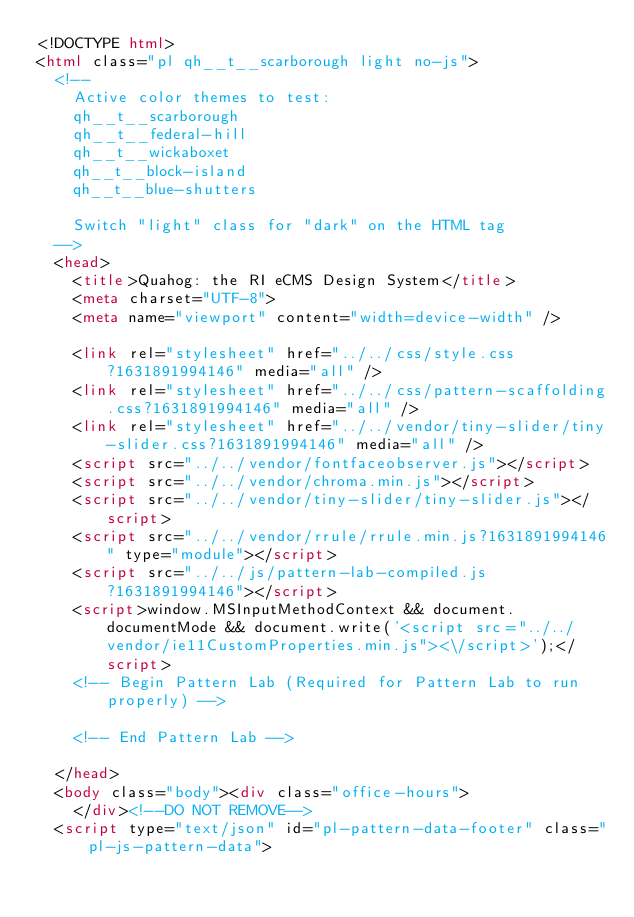Convert code to text. <code><loc_0><loc_0><loc_500><loc_500><_HTML_><!DOCTYPE html>
<html class="pl qh__t__scarborough light no-js">
  <!--
    Active color themes to test:
    qh__t__scarborough
    qh__t__federal-hill
    qh__t__wickaboxet
    qh__t__block-island
    qh__t__blue-shutters

    Switch "light" class for "dark" on the HTML tag
  -->
  <head>
    <title>Quahog: the RI eCMS Design System</title>
    <meta charset="UTF-8">
    <meta name="viewport" content="width=device-width" />

    <link rel="stylesheet" href="../../css/style.css?1631891994146" media="all" />
    <link rel="stylesheet" href="../../css/pattern-scaffolding.css?1631891994146" media="all" />
    <link rel="stylesheet" href="../../vendor/tiny-slider/tiny-slider.css?1631891994146" media="all" />
    <script src="../../vendor/fontfaceobserver.js"></script>
    <script src="../../vendor/chroma.min.js"></script>
    <script src="../../vendor/tiny-slider/tiny-slider.js"></script>
    <script src="../../vendor/rrule/rrule.min.js?1631891994146" type="module"></script>
    <script src="../../js/pattern-lab-compiled.js?1631891994146"></script>
    <script>window.MSInputMethodContext && document.documentMode && document.write('<script src="../../vendor/ie11CustomProperties.min.js"><\/script>');</script>
    <!-- Begin Pattern Lab (Required for Pattern Lab to run properly) -->
    
    <!-- End Pattern Lab -->

  </head>
  <body class="body"><div class="office-hours">
    </div><!--DO NOT REMOVE-->
  <script type="text/json" id="pl-pattern-data-footer" class="pl-js-pattern-data"></code> 